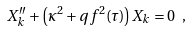<formula> <loc_0><loc_0><loc_500><loc_500>X _ { k } ^ { \prime \prime } + { \left ( \kappa ^ { 2 } + q f ^ { 2 } ( \tau ) \right ) } X _ { k } = 0 \ ,</formula> 